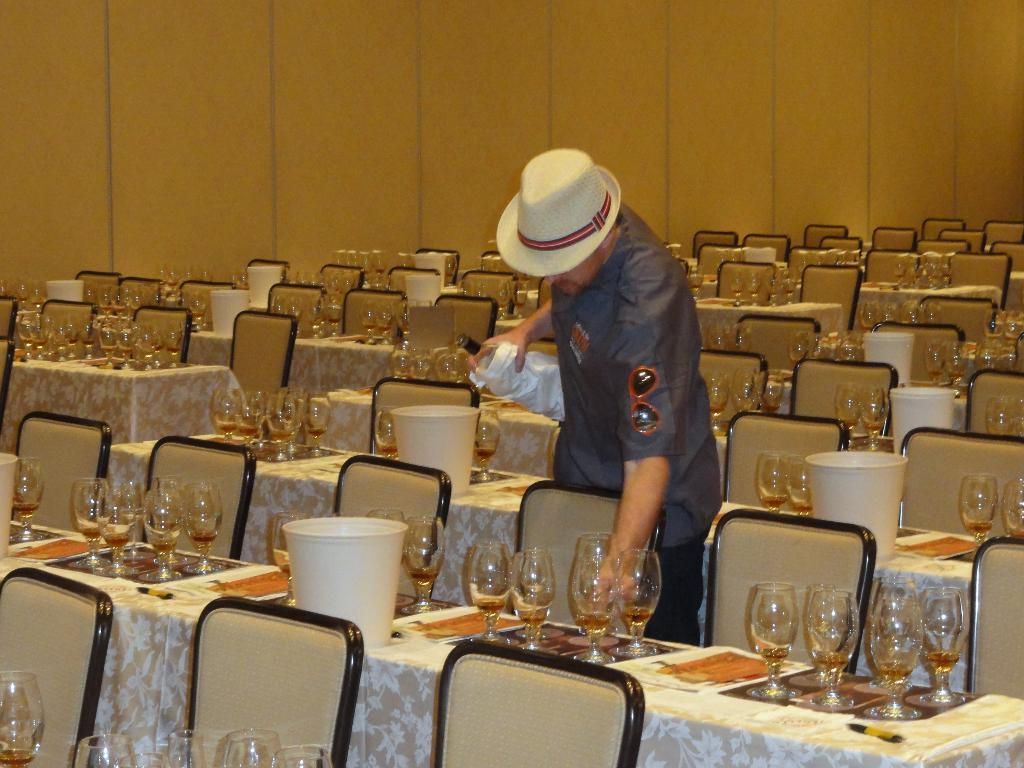What is the person in the image doing? The person is standing in the image and holding a bottle. What is the person wearing on their head? The person is wearing a hat. What type of furniture can be seen in the image? There are chairs and tables in the image. What objects are on the table? There are glasses on the table. What is visible in the background of the image? There is a wall in the background of the image. What type of pot is visible on the table in the image? There is no pot visible on the table in the image; only glasses are present. Can you see any corn or beans on the table in the image? There is no corn or beans present on the table in the image. 